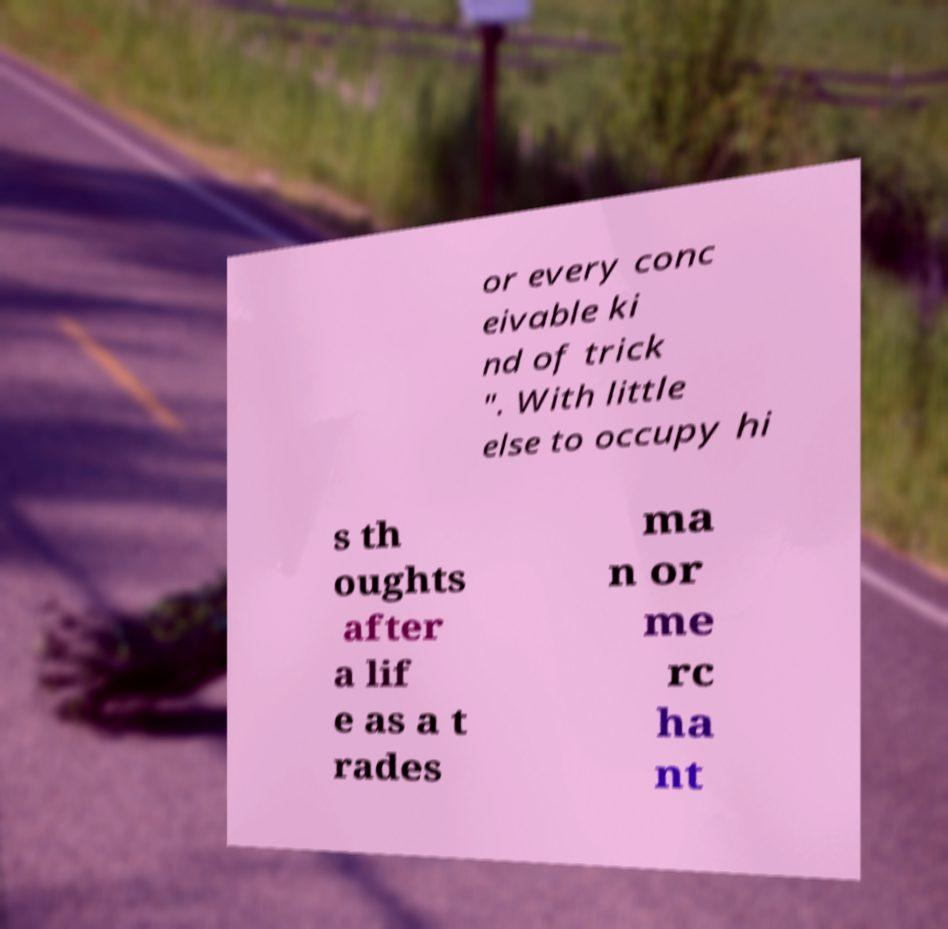There's text embedded in this image that I need extracted. Can you transcribe it verbatim? or every conc eivable ki nd of trick ". With little else to occupy hi s th oughts after a lif e as a t rades ma n or me rc ha nt 